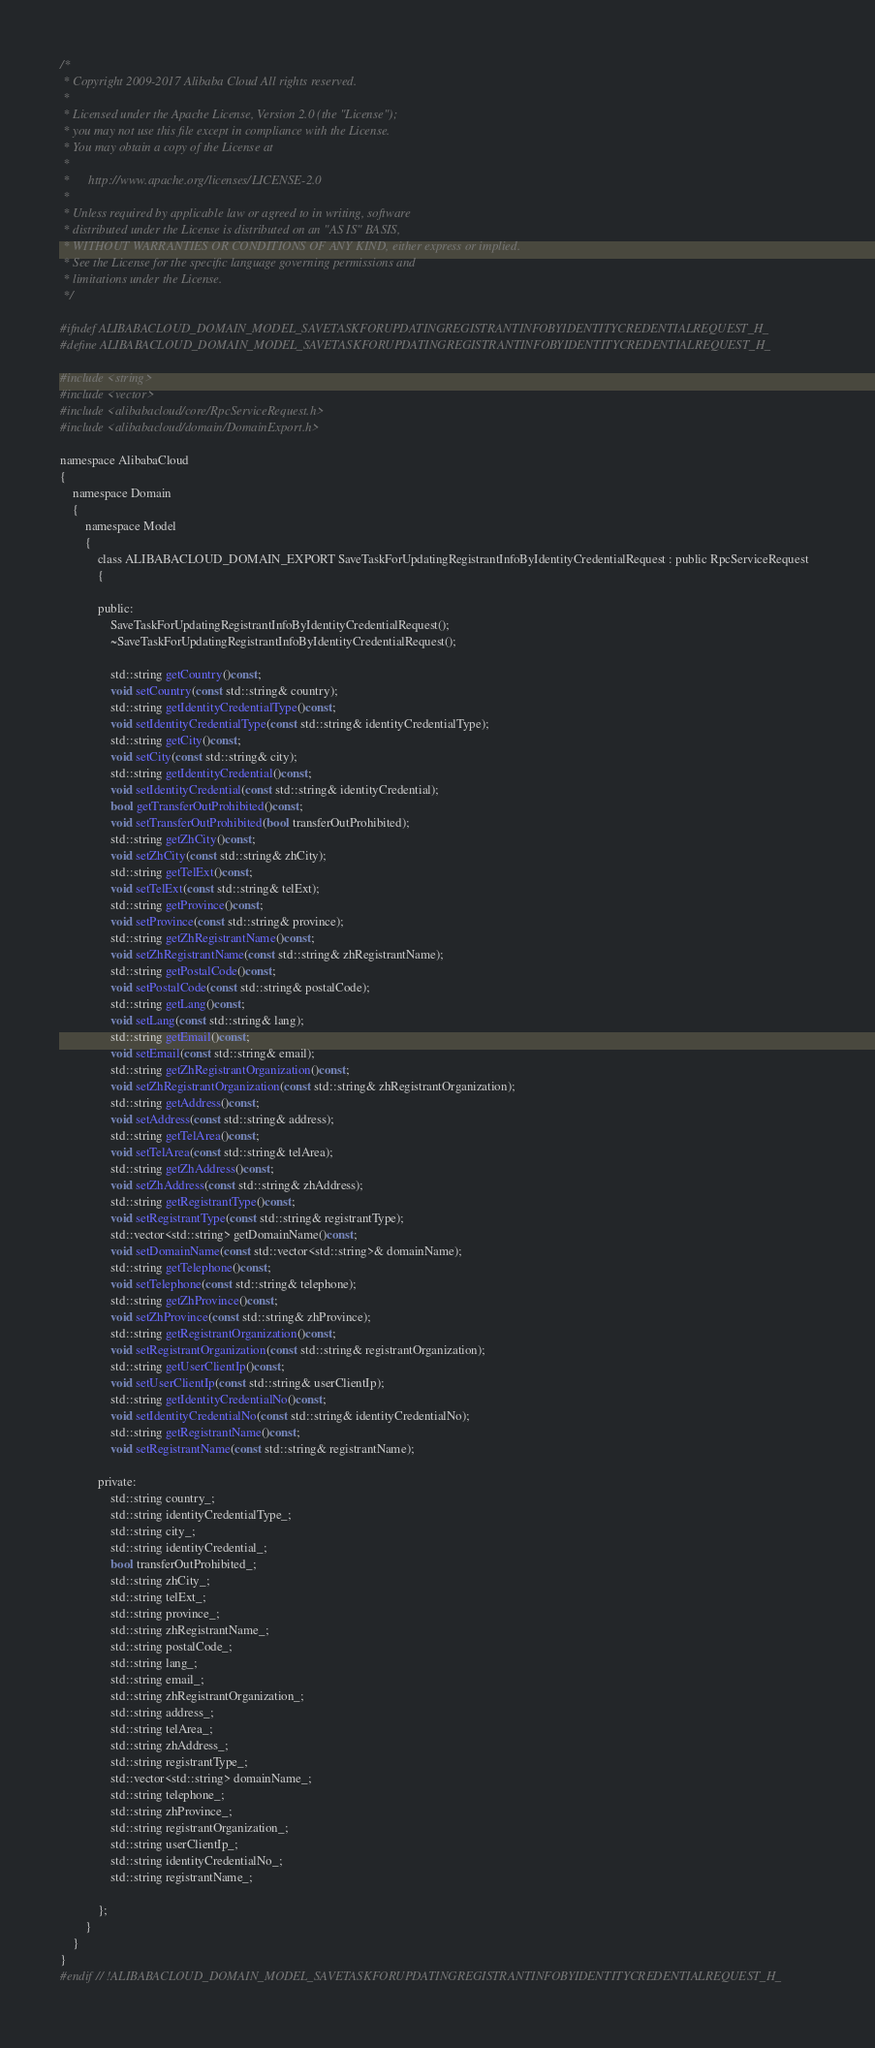<code> <loc_0><loc_0><loc_500><loc_500><_C_>/*
 * Copyright 2009-2017 Alibaba Cloud All rights reserved.
 * 
 * Licensed under the Apache License, Version 2.0 (the "License");
 * you may not use this file except in compliance with the License.
 * You may obtain a copy of the License at
 * 
 *      http://www.apache.org/licenses/LICENSE-2.0
 * 
 * Unless required by applicable law or agreed to in writing, software
 * distributed under the License is distributed on an "AS IS" BASIS,
 * WITHOUT WARRANTIES OR CONDITIONS OF ANY KIND, either express or implied.
 * See the License for the specific language governing permissions and
 * limitations under the License.
 */

#ifndef ALIBABACLOUD_DOMAIN_MODEL_SAVETASKFORUPDATINGREGISTRANTINFOBYIDENTITYCREDENTIALREQUEST_H_
#define ALIBABACLOUD_DOMAIN_MODEL_SAVETASKFORUPDATINGREGISTRANTINFOBYIDENTITYCREDENTIALREQUEST_H_

#include <string>
#include <vector>
#include <alibabacloud/core/RpcServiceRequest.h>
#include <alibabacloud/domain/DomainExport.h>

namespace AlibabaCloud
{
	namespace Domain
	{
		namespace Model
		{
			class ALIBABACLOUD_DOMAIN_EXPORT SaveTaskForUpdatingRegistrantInfoByIdentityCredentialRequest : public RpcServiceRequest
			{

			public:
				SaveTaskForUpdatingRegistrantInfoByIdentityCredentialRequest();
				~SaveTaskForUpdatingRegistrantInfoByIdentityCredentialRequest();

				std::string getCountry()const;
				void setCountry(const std::string& country);
				std::string getIdentityCredentialType()const;
				void setIdentityCredentialType(const std::string& identityCredentialType);
				std::string getCity()const;
				void setCity(const std::string& city);
				std::string getIdentityCredential()const;
				void setIdentityCredential(const std::string& identityCredential);
				bool getTransferOutProhibited()const;
				void setTransferOutProhibited(bool transferOutProhibited);
				std::string getZhCity()const;
				void setZhCity(const std::string& zhCity);
				std::string getTelExt()const;
				void setTelExt(const std::string& telExt);
				std::string getProvince()const;
				void setProvince(const std::string& province);
				std::string getZhRegistrantName()const;
				void setZhRegistrantName(const std::string& zhRegistrantName);
				std::string getPostalCode()const;
				void setPostalCode(const std::string& postalCode);
				std::string getLang()const;
				void setLang(const std::string& lang);
				std::string getEmail()const;
				void setEmail(const std::string& email);
				std::string getZhRegistrantOrganization()const;
				void setZhRegistrantOrganization(const std::string& zhRegistrantOrganization);
				std::string getAddress()const;
				void setAddress(const std::string& address);
				std::string getTelArea()const;
				void setTelArea(const std::string& telArea);
				std::string getZhAddress()const;
				void setZhAddress(const std::string& zhAddress);
				std::string getRegistrantType()const;
				void setRegistrantType(const std::string& registrantType);
				std::vector<std::string> getDomainName()const;
				void setDomainName(const std::vector<std::string>& domainName);
				std::string getTelephone()const;
				void setTelephone(const std::string& telephone);
				std::string getZhProvince()const;
				void setZhProvince(const std::string& zhProvince);
				std::string getRegistrantOrganization()const;
				void setRegistrantOrganization(const std::string& registrantOrganization);
				std::string getUserClientIp()const;
				void setUserClientIp(const std::string& userClientIp);
				std::string getIdentityCredentialNo()const;
				void setIdentityCredentialNo(const std::string& identityCredentialNo);
				std::string getRegistrantName()const;
				void setRegistrantName(const std::string& registrantName);

            private:
				std::string country_;
				std::string identityCredentialType_;
				std::string city_;
				std::string identityCredential_;
				bool transferOutProhibited_;
				std::string zhCity_;
				std::string telExt_;
				std::string province_;
				std::string zhRegistrantName_;
				std::string postalCode_;
				std::string lang_;
				std::string email_;
				std::string zhRegistrantOrganization_;
				std::string address_;
				std::string telArea_;
				std::string zhAddress_;
				std::string registrantType_;
				std::vector<std::string> domainName_;
				std::string telephone_;
				std::string zhProvince_;
				std::string registrantOrganization_;
				std::string userClientIp_;
				std::string identityCredentialNo_;
				std::string registrantName_;

			};
		}
	}
}
#endif // !ALIBABACLOUD_DOMAIN_MODEL_SAVETASKFORUPDATINGREGISTRANTINFOBYIDENTITYCREDENTIALREQUEST_H_</code> 